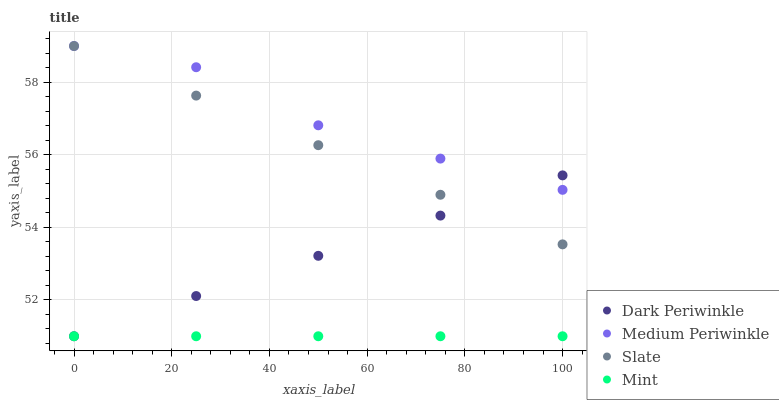Does Mint have the minimum area under the curve?
Answer yes or no. Yes. Does Medium Periwinkle have the maximum area under the curve?
Answer yes or no. Yes. Does Slate have the minimum area under the curve?
Answer yes or no. No. Does Slate have the maximum area under the curve?
Answer yes or no. No. Is Mint the smoothest?
Answer yes or no. Yes. Is Medium Periwinkle the roughest?
Answer yes or no. Yes. Is Medium Periwinkle the smoothest?
Answer yes or no. No. Is Slate the roughest?
Answer yes or no. No. Does Mint have the lowest value?
Answer yes or no. Yes. Does Slate have the lowest value?
Answer yes or no. No. Does Medium Periwinkle have the highest value?
Answer yes or no. Yes. Does Dark Periwinkle have the highest value?
Answer yes or no. No. Is Mint less than Medium Periwinkle?
Answer yes or no. Yes. Is Medium Periwinkle greater than Mint?
Answer yes or no. Yes. Does Medium Periwinkle intersect Slate?
Answer yes or no. Yes. Is Medium Periwinkle less than Slate?
Answer yes or no. No. Is Medium Periwinkle greater than Slate?
Answer yes or no. No. Does Mint intersect Medium Periwinkle?
Answer yes or no. No. 